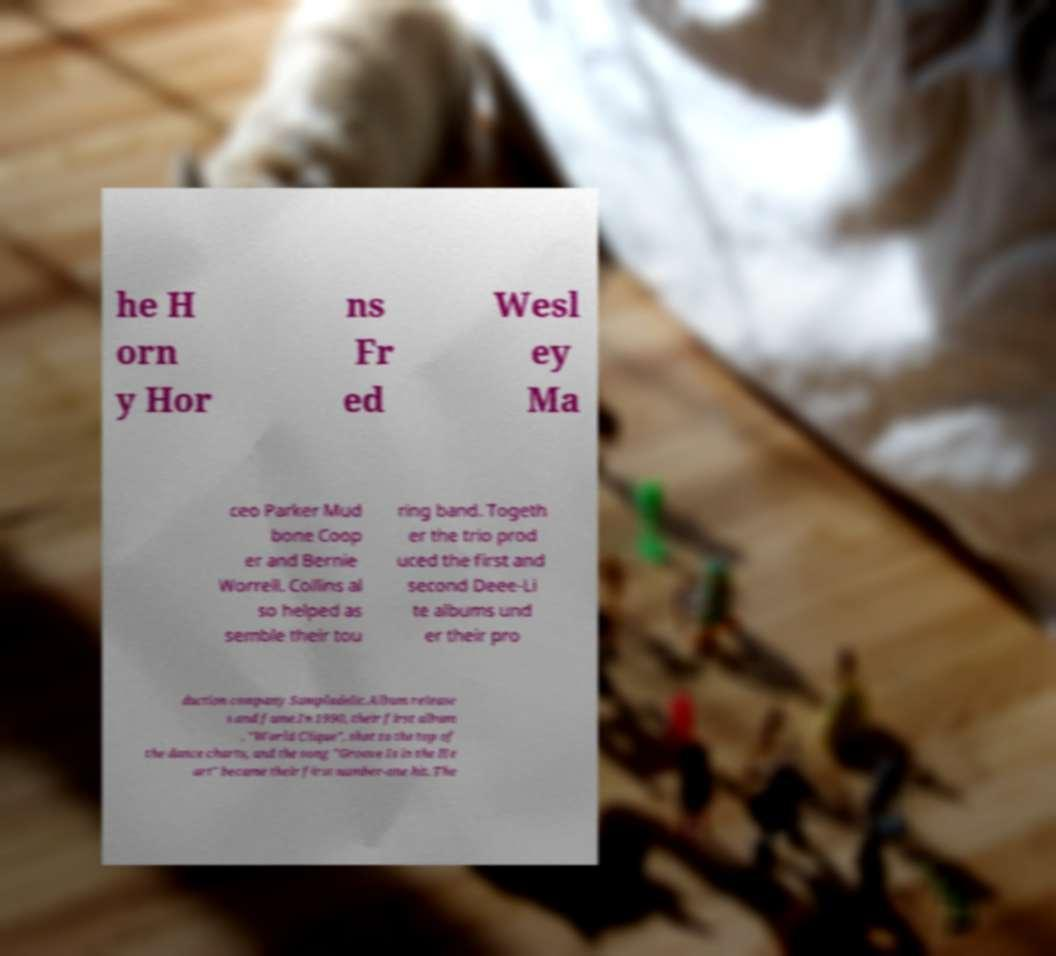Please read and relay the text visible in this image. What does it say? he H orn y Hor ns Fr ed Wesl ey Ma ceo Parker Mud bone Coop er and Bernie Worrell. Collins al so helped as semble their tou ring band. Togeth er the trio prod uced the first and second Deee-Li te albums und er their pro duction company Sampladelic.Album release s and fame.In 1990, their first album , "World Clique", shot to the top of the dance charts, and the song "Groove Is in the He art" became their first number-one hit. The 